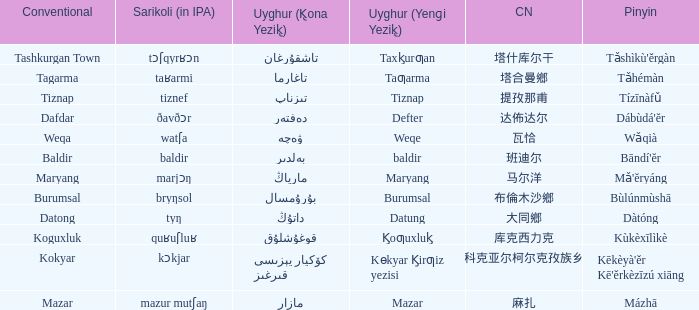Name the conventional for defter Dafdar. 